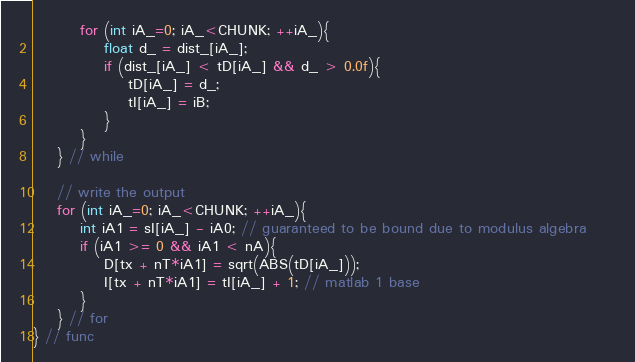<code> <loc_0><loc_0><loc_500><loc_500><_Cuda_>        for (int iA_=0; iA_<CHUNK; ++iA_){
            float d_ = dist_[iA_];
            if (dist_[iA_] < tD[iA_] && d_ > 0.0f){
                tD[iA_] = d_;
                tI[iA_] = iB;
            }
        }
    } // while
    
    // write the output
    for (int iA_=0; iA_<CHUNK; ++iA_){ 
        int iA1 = sI[iA_] - iA0; // guaranteed to be bound due to modulus algebra     
        if (iA1 >= 0 && iA1 < nA){
            D[tx + nT*iA1] = sqrt(ABS(tD[iA_]));
            I[tx + nT*iA1] = tI[iA_] + 1; // matlab 1 base
        }
    } // for
} // func
</code> 